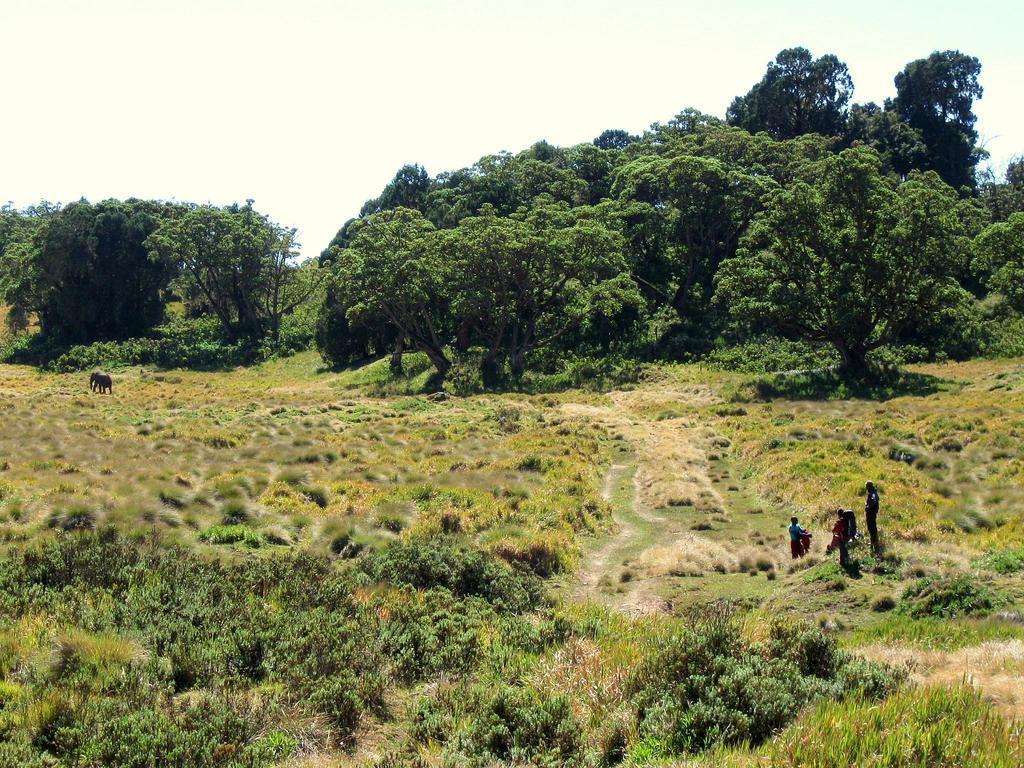Please provide a concise description of this image. In the image there are many plants and trees, there are three people on the right side and on the left side there is an elephant. 